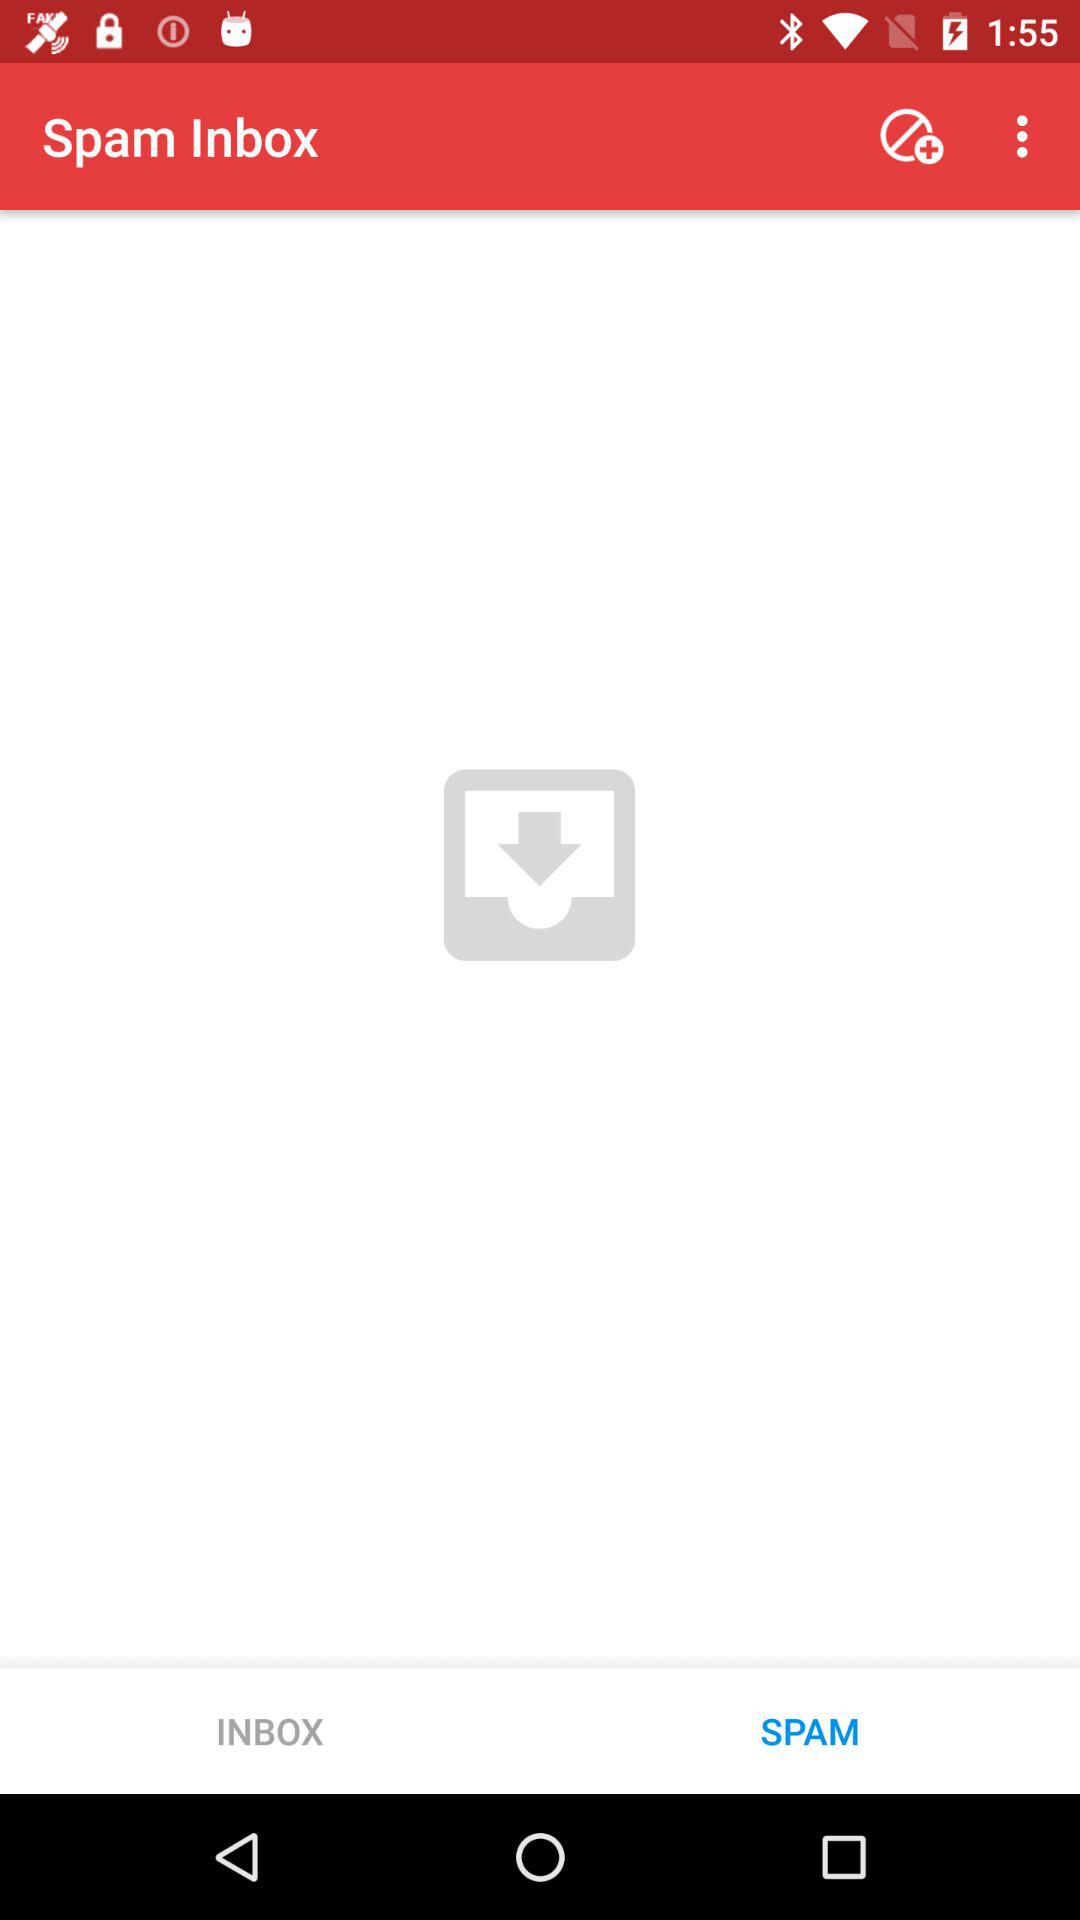How many spam items are in the inbox?
When the provided information is insufficient, respond with <no answer>. <no answer> 